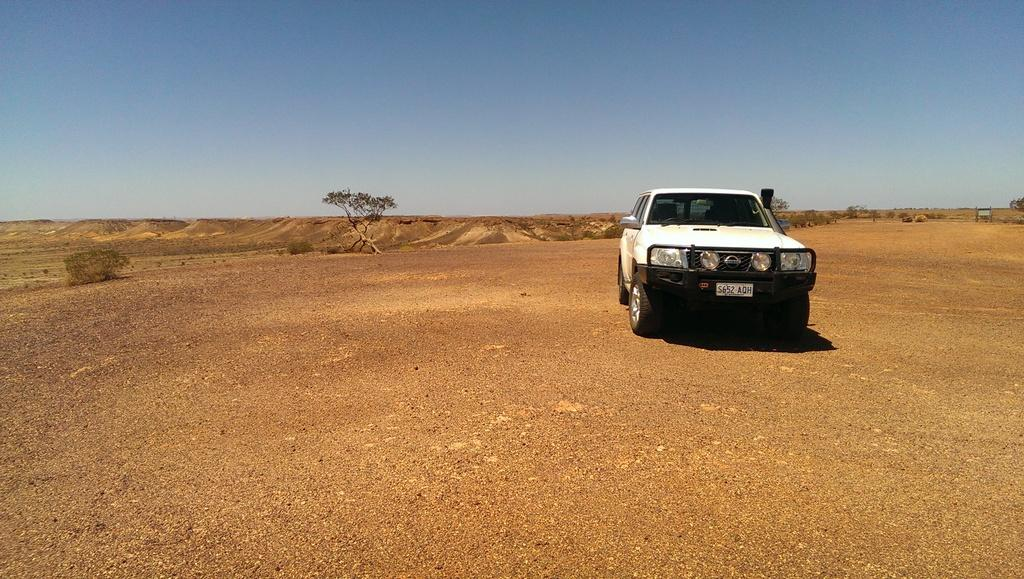What is the main subject of the image? The main subject of the image is a car. Can you describe the position of the car in the image? The car is on the ground in the image. What can be seen on the car that helps identify it? The car has a number plate in the image. What is visible behind the car? There is a tree and plants behind the car in the image. What is visible part of the natural environment can be seen in the image? The sky is visible at the top of the image. How does the kettle begin to limit the car's movement in the image? There is no kettle present in the image, so it cannot limit the car's movement. 